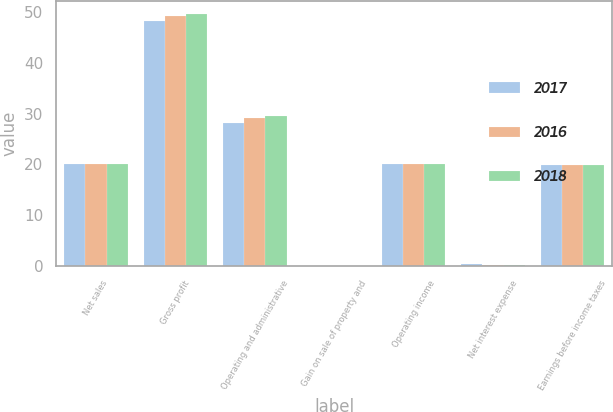Convert chart to OTSL. <chart><loc_0><loc_0><loc_500><loc_500><stacked_bar_chart><ecel><fcel>Net sales<fcel>Gross profit<fcel>Operating and administrative<fcel>Gain on sale of property and<fcel>Operating income<fcel>Net interest expense<fcel>Earnings before income taxes<nl><fcel>2017<fcel>20<fcel>48.3<fcel>28.2<fcel>0<fcel>20.1<fcel>0.3<fcel>19.9<nl><fcel>2016<fcel>20<fcel>49.3<fcel>29.2<fcel>0<fcel>20.1<fcel>0.2<fcel>19.9<nl><fcel>2018<fcel>20<fcel>49.6<fcel>29.5<fcel>0<fcel>20.1<fcel>0.2<fcel>19.9<nl></chart> 